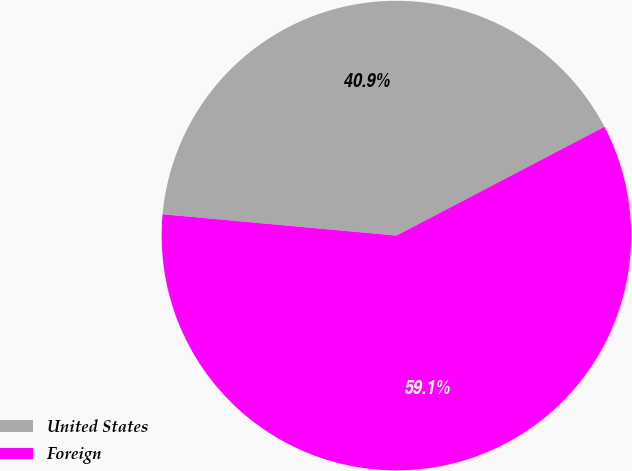Convert chart. <chart><loc_0><loc_0><loc_500><loc_500><pie_chart><fcel>United States<fcel>Foreign<nl><fcel>40.88%<fcel>59.12%<nl></chart> 